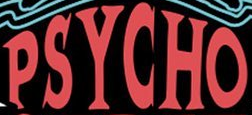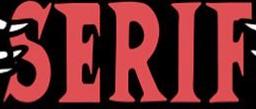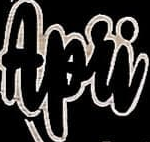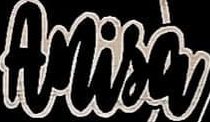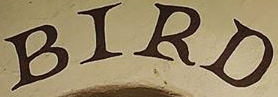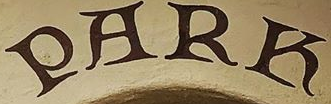Read the text from these images in sequence, separated by a semicolon. PSYCHO; SERIF; Apri; Anisa; BIRD; PARK 